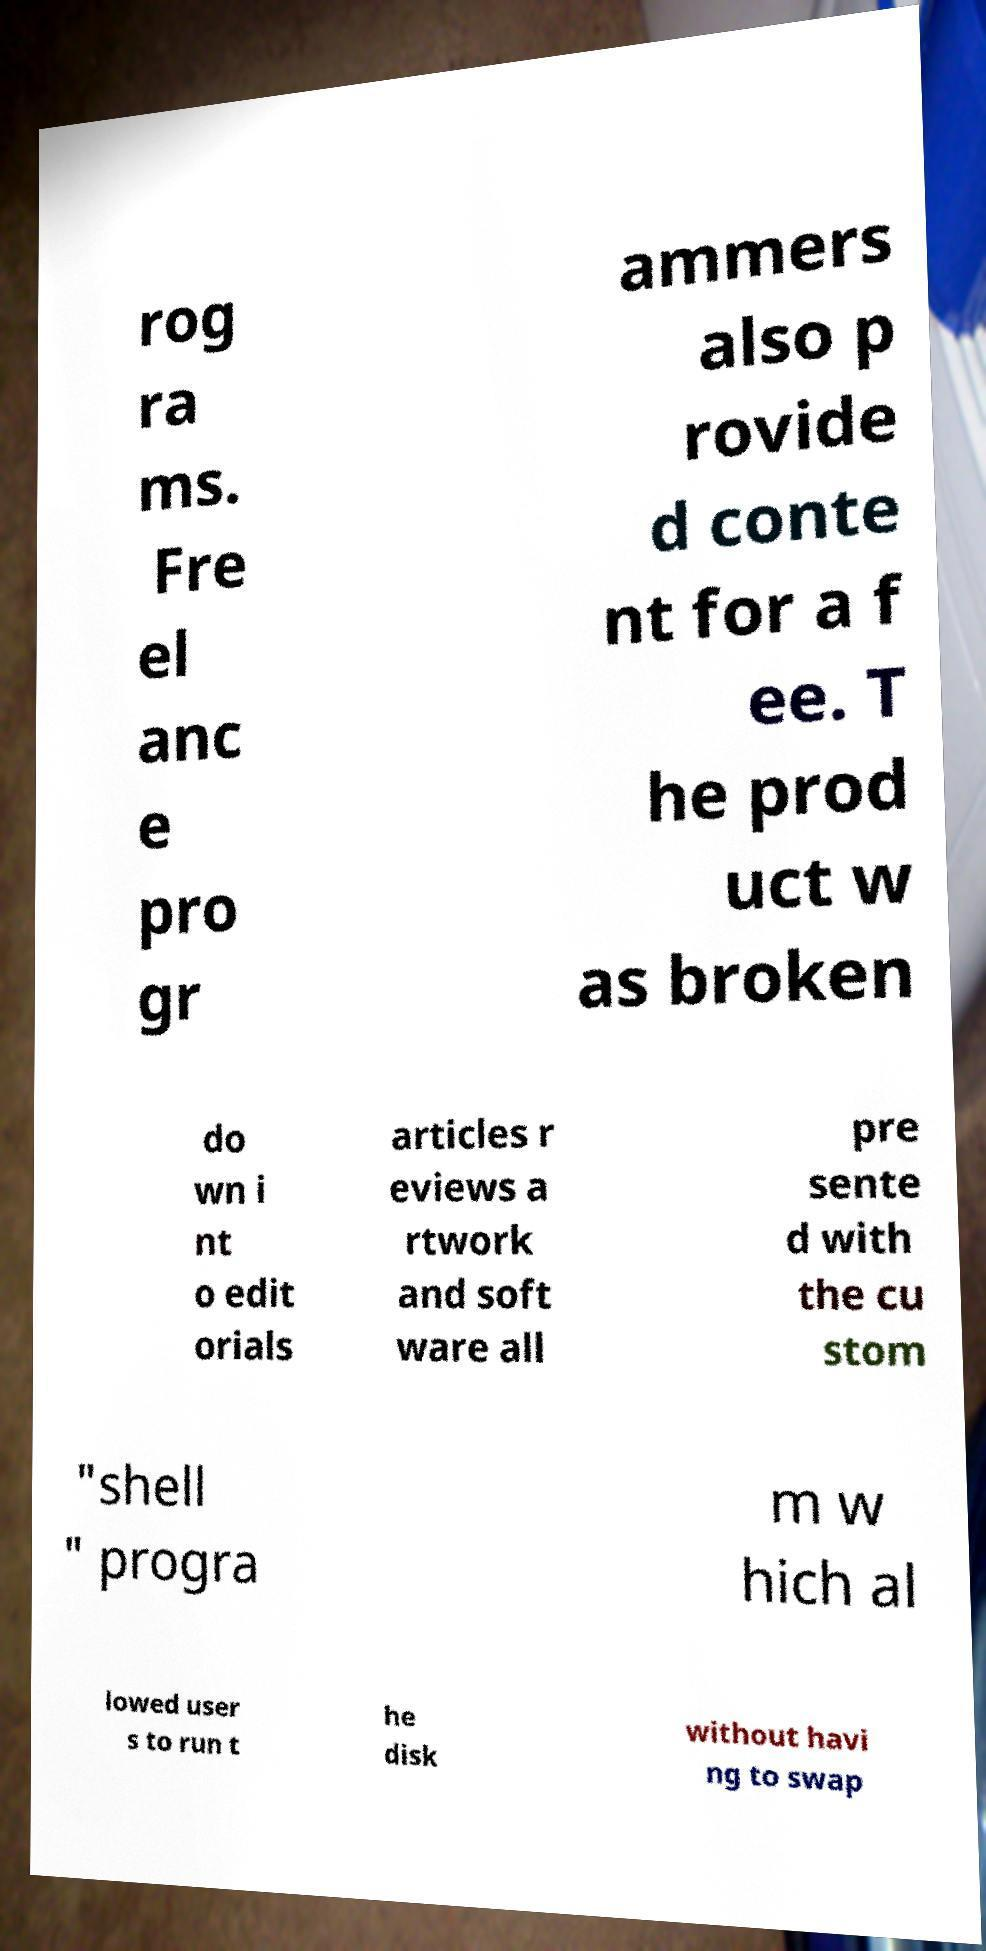For documentation purposes, I need the text within this image transcribed. Could you provide that? rog ra ms. Fre el anc e pro gr ammers also p rovide d conte nt for a f ee. T he prod uct w as broken do wn i nt o edit orials articles r eviews a rtwork and soft ware all pre sente d with the cu stom "shell " progra m w hich al lowed user s to run t he disk without havi ng to swap 